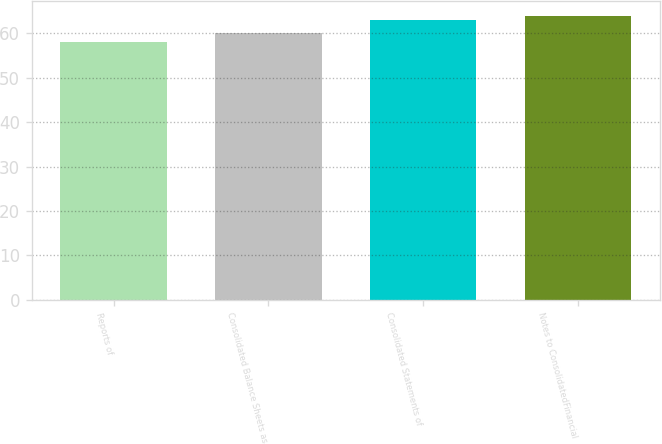Convert chart. <chart><loc_0><loc_0><loc_500><loc_500><bar_chart><fcel>Reports of<fcel>Consolidated Balance Sheets as<fcel>Consolidated Statements of<fcel>Notes to ConsolidatedFinancial<nl><fcel>58<fcel>60<fcel>63<fcel>64<nl></chart> 